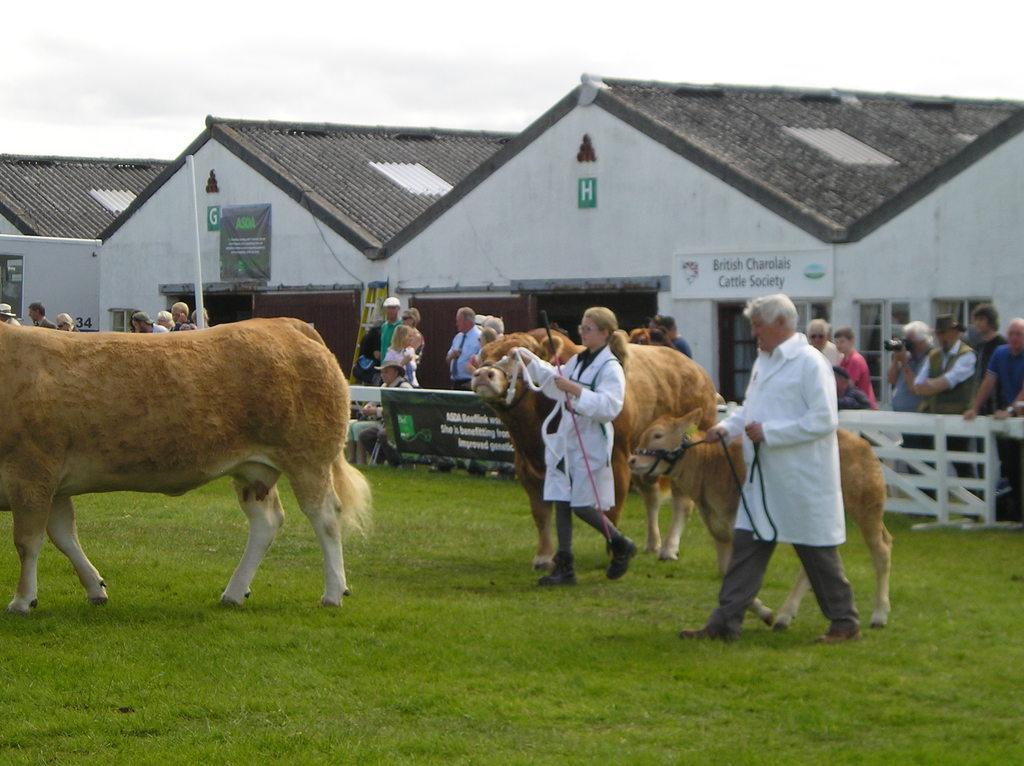Can you describe this image briefly? In this picture we can see animals, grass, man and woman on the ground, she is holding a rope, stick with her hands, man is holding a rope, at the back of them we can see a fence and a group of people, one person is holding a camera, here we can see sheds, name board, banner, letter boards, pole, ladder and some objects and we can see sky in the background. 